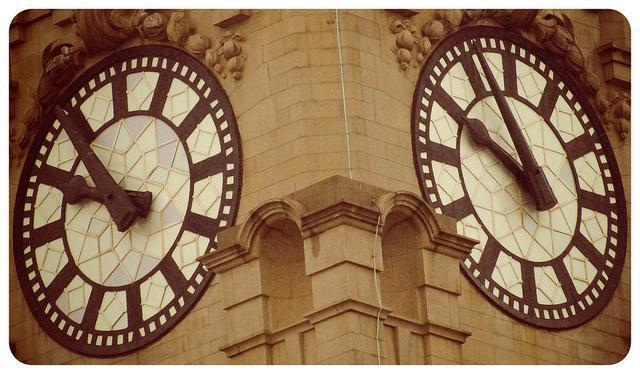How many clocks are there?
Give a very brief answer. 2. 